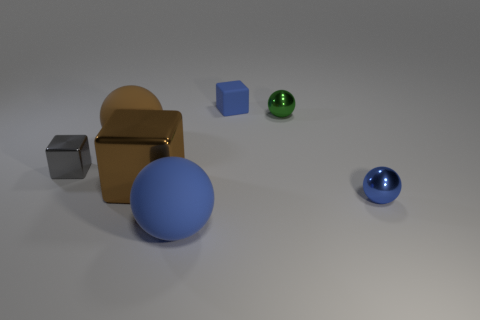Subtract all green blocks. How many blue balls are left? 2 Subtract all tiny blocks. How many blocks are left? 1 Add 1 small yellow shiny cubes. How many objects exist? 8 Subtract all green spheres. How many spheres are left? 3 Subtract 2 spheres. How many spheres are left? 2 Subtract all red spheres. Subtract all gray cubes. How many spheres are left? 4 Subtract all balls. How many objects are left? 3 Add 2 big blocks. How many big blocks are left? 3 Add 7 metallic cubes. How many metallic cubes exist? 9 Subtract 1 blue cubes. How many objects are left? 6 